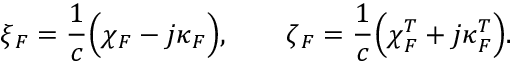<formula> <loc_0><loc_0><loc_500><loc_500>\ = \xi _ { \/ F } = \frac { 1 } { c } \left ( \ = \chi _ { \/ F } - j \ = \kappa _ { \/ F } \right ) , \quad \ = \zeta _ { \/ F } = \frac { 1 } { c } \left ( \ = \chi _ { \/ F } ^ { T } + j \ = \kappa _ { \/ F } ^ { T } \right ) .</formula> 